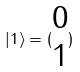<formula> <loc_0><loc_0><loc_500><loc_500>| 1 \rangle = ( \begin{matrix} 0 \\ 1 \end{matrix} )</formula> 